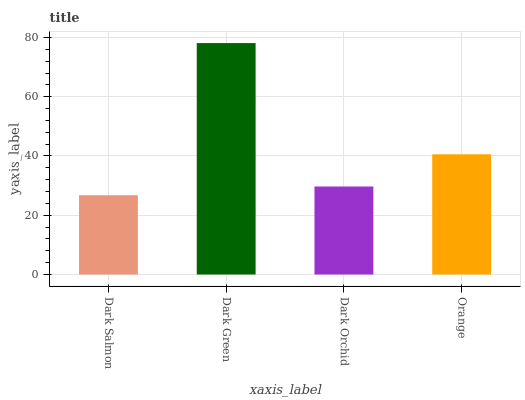Is Dark Salmon the minimum?
Answer yes or no. Yes. Is Dark Green the maximum?
Answer yes or no. Yes. Is Dark Orchid the minimum?
Answer yes or no. No. Is Dark Orchid the maximum?
Answer yes or no. No. Is Dark Green greater than Dark Orchid?
Answer yes or no. Yes. Is Dark Orchid less than Dark Green?
Answer yes or no. Yes. Is Dark Orchid greater than Dark Green?
Answer yes or no. No. Is Dark Green less than Dark Orchid?
Answer yes or no. No. Is Orange the high median?
Answer yes or no. Yes. Is Dark Orchid the low median?
Answer yes or no. Yes. Is Dark Green the high median?
Answer yes or no. No. Is Dark Green the low median?
Answer yes or no. No. 